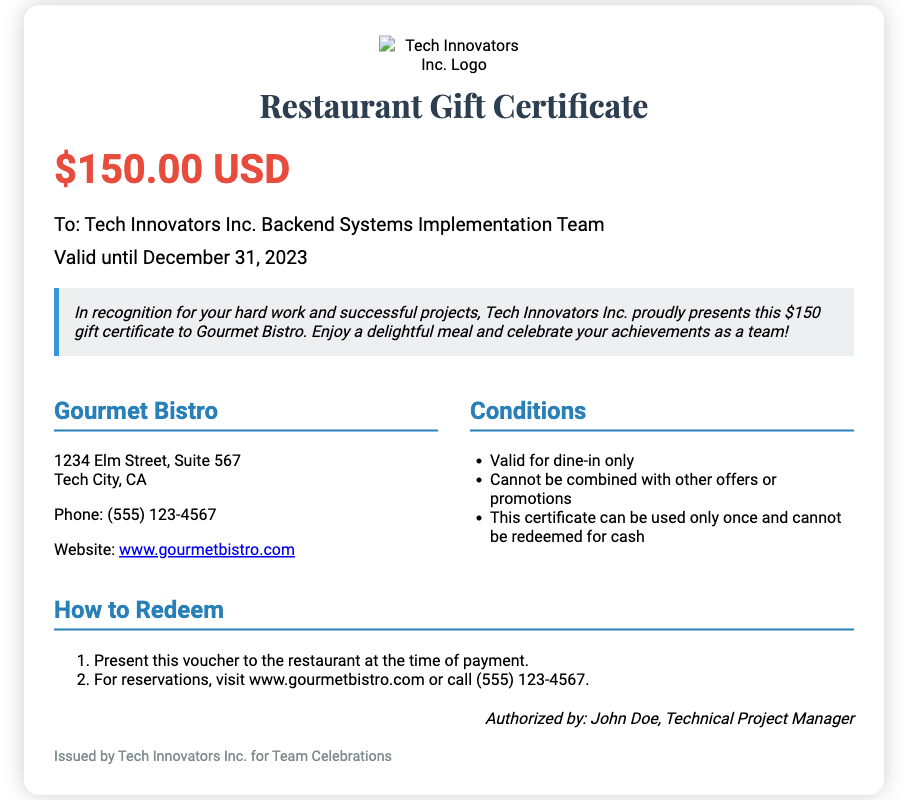What is the value of the gift certificate? The gift certificate is valued at $150.00 USD, which is mentioned prominently in the document.
Answer: $150.00 USD Who is the recipient of the gift certificate? The recipient is specified as "Tech Innovators Inc. Backend Systems Implementation Team" in the document.
Answer: Tech Innovators Inc. Backend Systems Implementation Team What is the expiration date of the gift certificate? The document states that the validity of the gift certificate extends until December 31, 2023.
Answer: December 31, 2023 Where is Gourmet Bistro located? The address of Gourmet Bistro is given as "1234 Elm Street, Suite 567, Tech City, CA" in the document.
Answer: 1234 Elm Street, Suite 567, Tech City, CA What is one condition mentioned for using the gift certificate? One of the conditions listed states that the gift certificate is valid for dine-in only.
Answer: Valid for dine-in only What is required to redeem the certificate? The document indicates that the certificate must be presented to the restaurant at the time of payment for redemption.
Answer: Present this voucher to the restaurant at the time of payment Who authorized the gift certificate? The authorized person is named as John Doe, who is the Technical Project Manager in the document.
Answer: John Doe How many offers or promotions can this gift certificate be combined with? The document specifies that the gift certificate cannot be combined with other offers or promotions, indicating a singular use.
Answer: Cannot be combined with other offers or promotions 